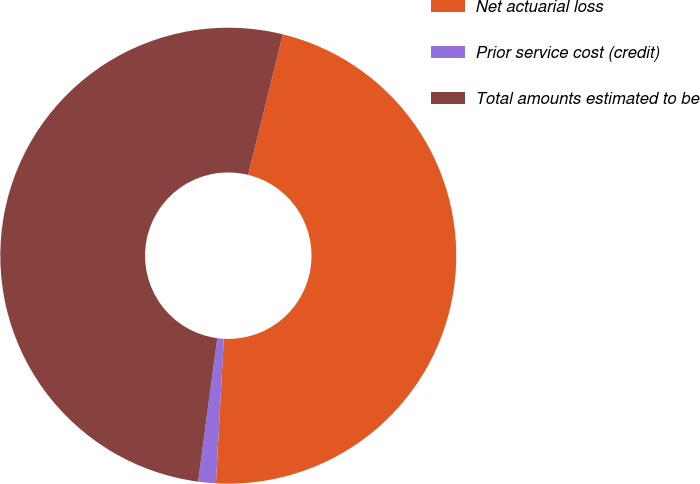Convert chart. <chart><loc_0><loc_0><loc_500><loc_500><pie_chart><fcel>Net actuarial loss<fcel>Prior service cost (credit)<fcel>Total amounts estimated to be<nl><fcel>47.02%<fcel>1.25%<fcel>51.73%<nl></chart> 